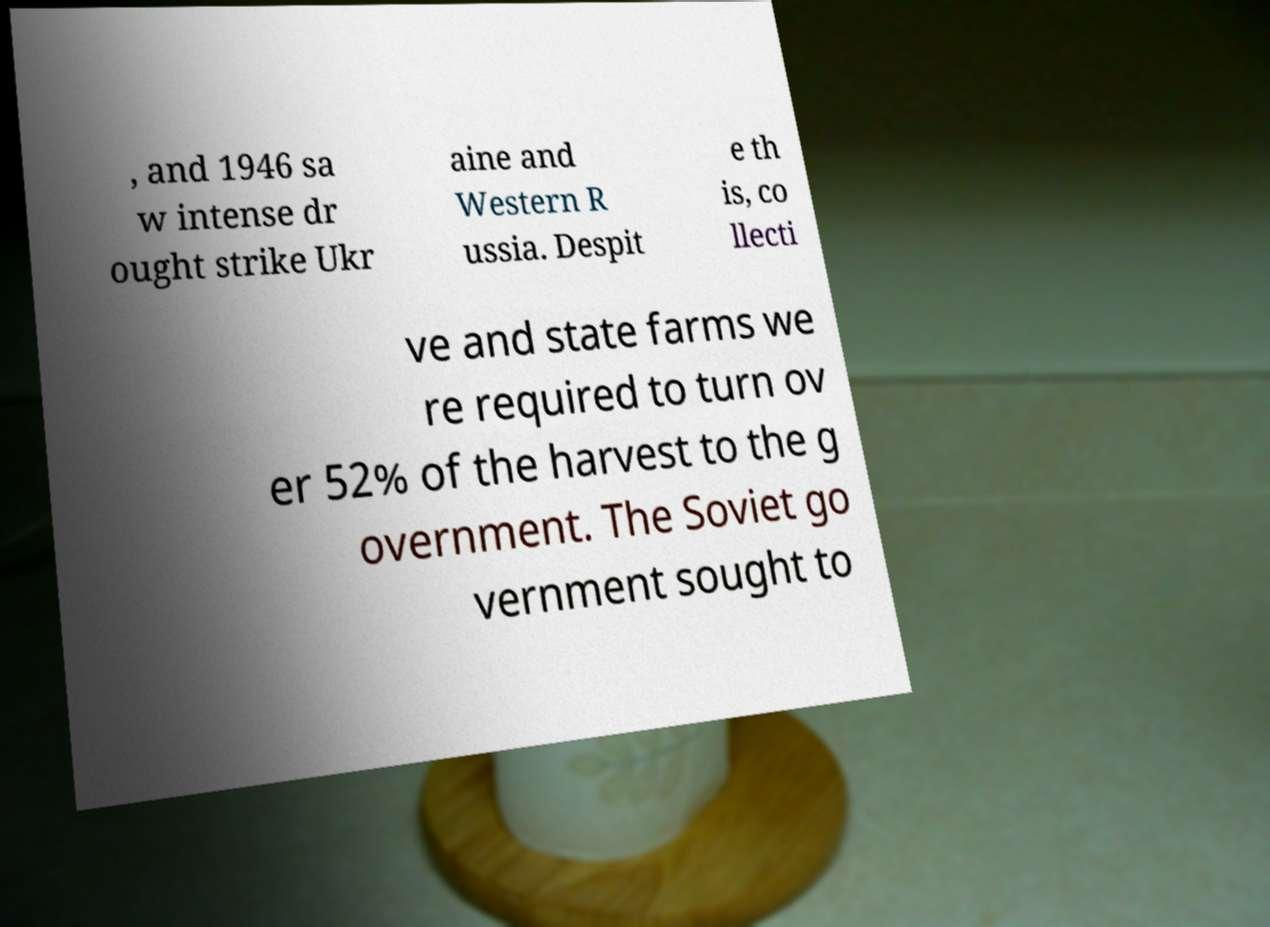For documentation purposes, I need the text within this image transcribed. Could you provide that? , and 1946 sa w intense dr ought strike Ukr aine and Western R ussia. Despit e th is, co llecti ve and state farms we re required to turn ov er 52% of the harvest to the g overnment. The Soviet go vernment sought to 